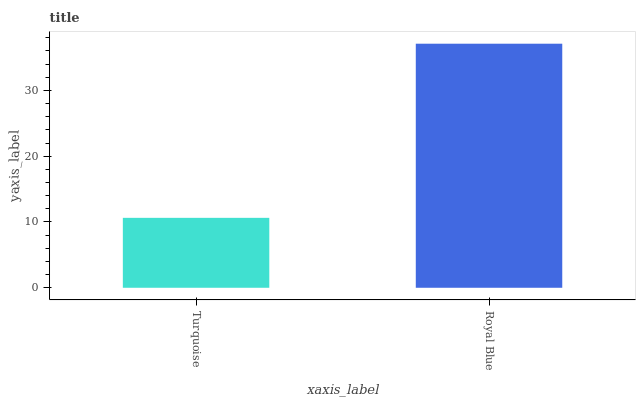Is Turquoise the minimum?
Answer yes or no. Yes. Is Royal Blue the maximum?
Answer yes or no. Yes. Is Royal Blue the minimum?
Answer yes or no. No. Is Royal Blue greater than Turquoise?
Answer yes or no. Yes. Is Turquoise less than Royal Blue?
Answer yes or no. Yes. Is Turquoise greater than Royal Blue?
Answer yes or no. No. Is Royal Blue less than Turquoise?
Answer yes or no. No. Is Royal Blue the high median?
Answer yes or no. Yes. Is Turquoise the low median?
Answer yes or no. Yes. Is Turquoise the high median?
Answer yes or no. No. Is Royal Blue the low median?
Answer yes or no. No. 